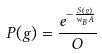Convert formula to latex. <formula><loc_0><loc_0><loc_500><loc_500>P ( g ) = \frac { e ^ { - \frac { S ( g ) } { w _ { B } A } } } { O }</formula> 